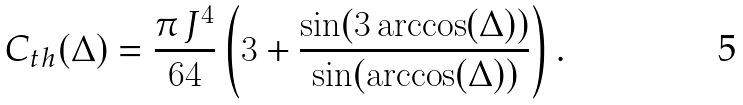Convert formula to latex. <formula><loc_0><loc_0><loc_500><loc_500>C _ { t h } ( \Delta ) = \frac { \pi \, J ^ { 4 } } { 6 4 } \left ( 3 + \frac { \sin ( 3 \arccos ( \Delta ) ) } { \sin ( \arccos ( \Delta ) ) } \right ) .</formula> 